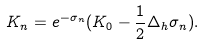<formula> <loc_0><loc_0><loc_500><loc_500>K _ { n } = e ^ { - \sigma _ { n } } ( K _ { 0 } - \frac { 1 } { 2 } \Delta _ { h } \sigma _ { n } ) .</formula> 